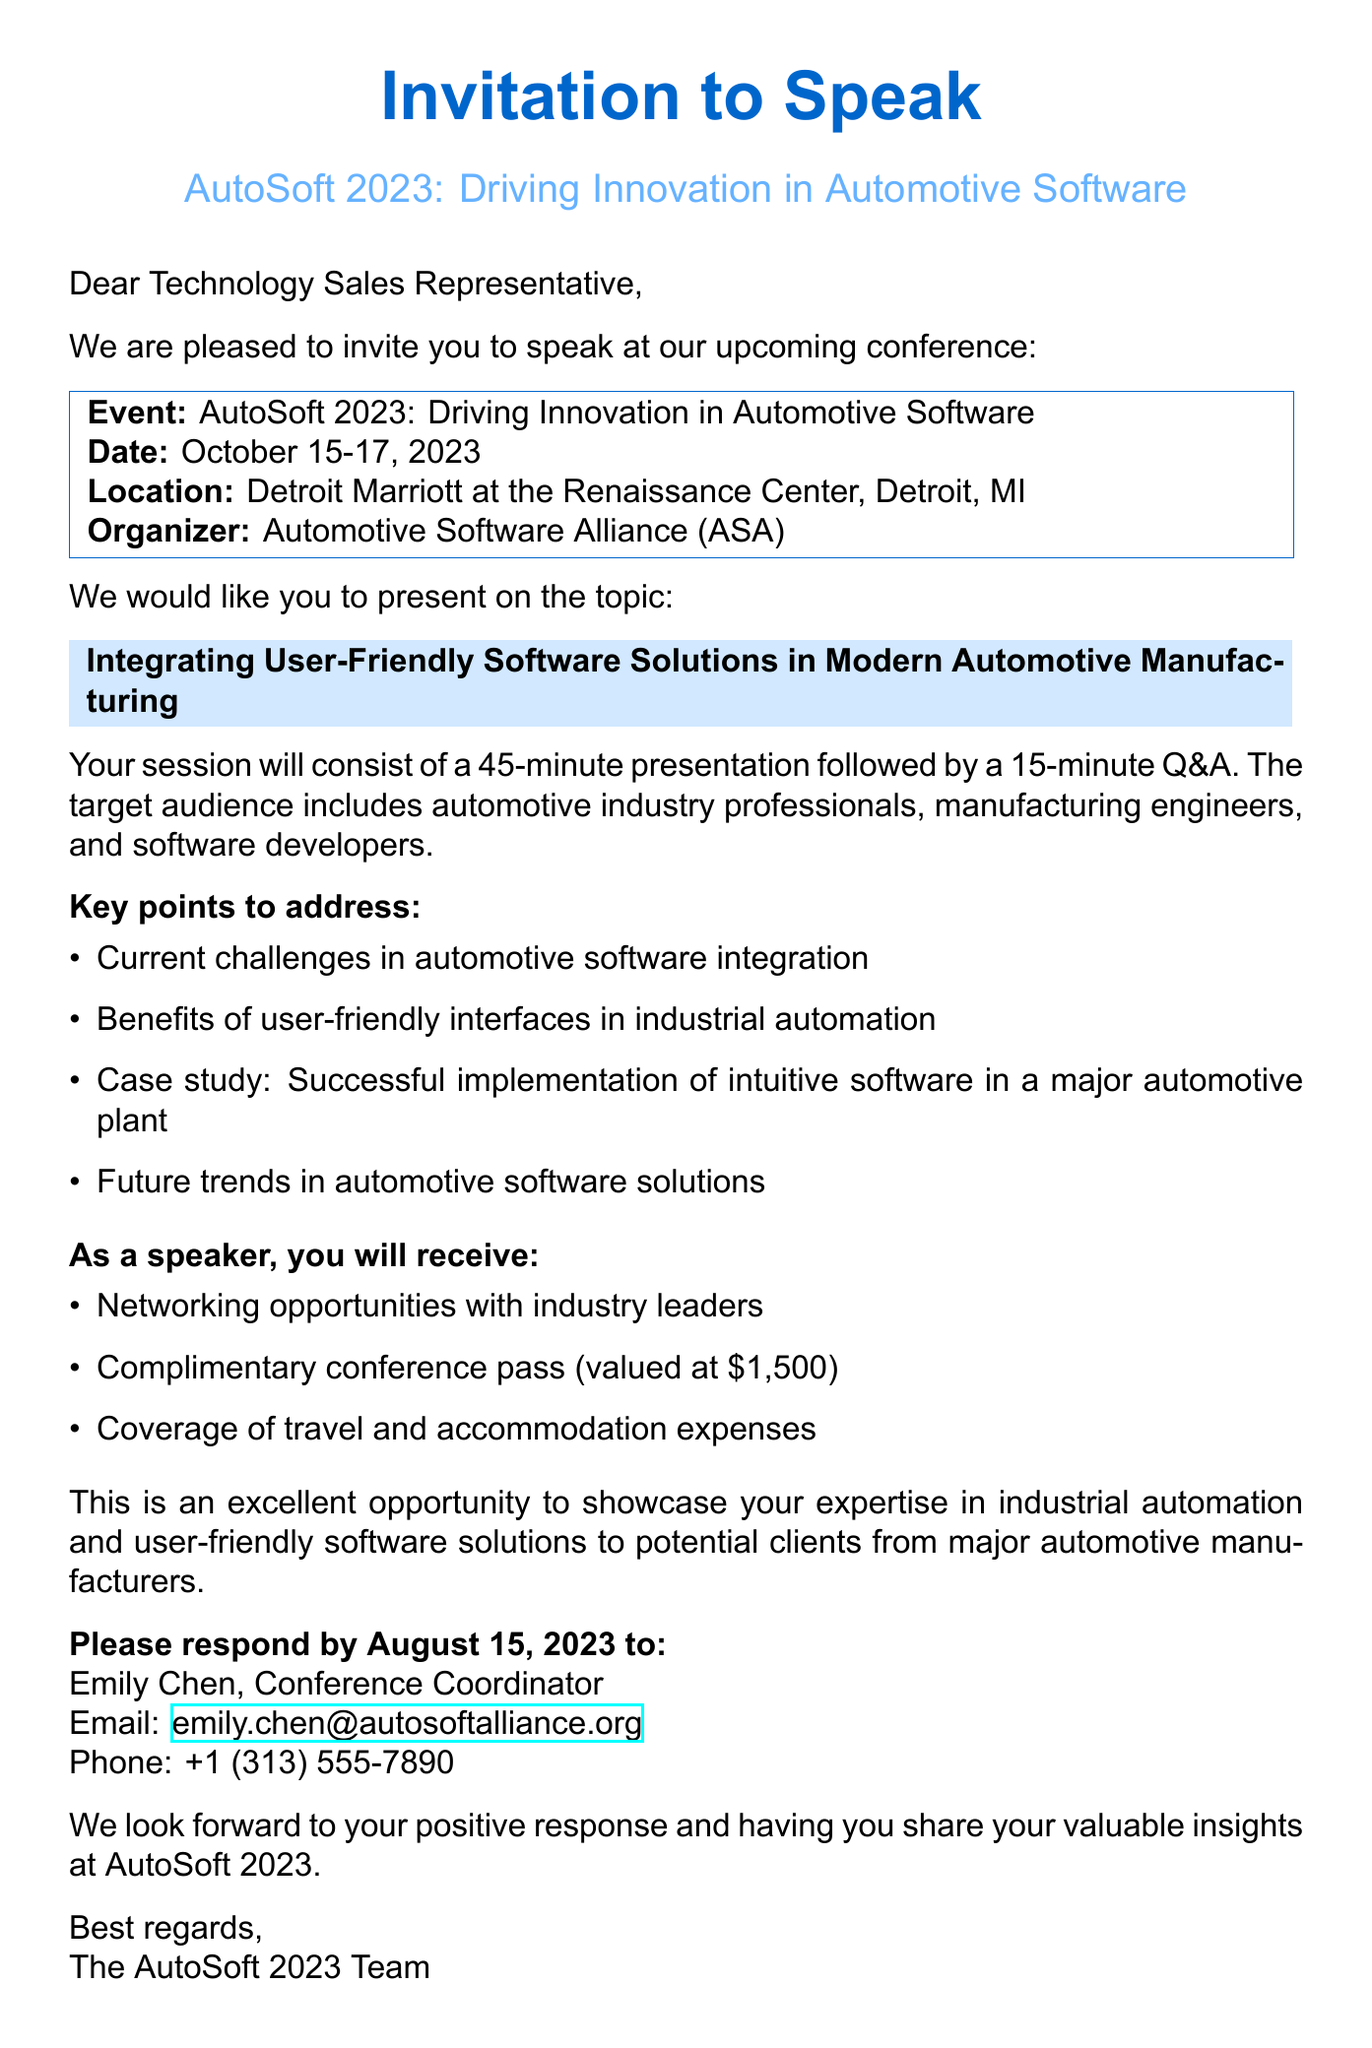What is the name of the conference? The conference is called AutoSoft 2023: Driving Innovation in Automotive Software.
Answer: AutoSoft 2023: Driving Innovation in Automotive Software What are the dates of the conference? The conference is scheduled for October 15-17, 2023.
Answer: October 15-17, 2023 Who is the conference organizer? The email states that the organizer is the Automotive Software Alliance (ASA).
Answer: Automotive Software Alliance (ASA) What is the duration of the presentation and Q&A session? The speaker is expected to deliver a 45-minute presentation followed by a 15-minute Q&A.
Answer: 45-minute presentation followed by 15-minute Q&A What key point addresses the implementation of software solutions? A key point includes discussing a case study on successful implementation of intuitive software in a major automotive plant.
Answer: Case study: Successful implementation of intuitive software in a major automotive plant What is one benefit of being a speaker at the conference? One of the benefits listed is networking opportunities with industry leaders.
Answer: Networking opportunities with industry leaders What is the response deadline for the invitation? The response deadline to the email is stated as August 15, 2023.
Answer: August 15, 2023 Who should the response be sent to? The response should be sent to Emily Chen, the Conference Coordinator.
Answer: Emily Chen What is the value of the complimentary conference pass? The document indicates that the value of the complimentary conference pass is $1,500.
Answer: $1,500 